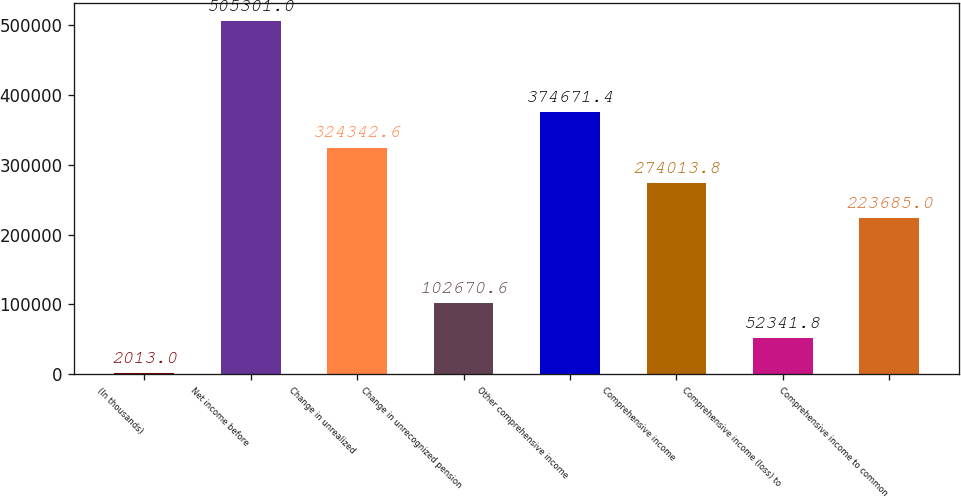<chart> <loc_0><loc_0><loc_500><loc_500><bar_chart><fcel>(In thousands)<fcel>Net income before<fcel>Change in unrealized<fcel>Change in unrecognized pension<fcel>Other comprehensive income<fcel>Comprehensive income<fcel>Comprehensive income (loss) to<fcel>Comprehensive income to common<nl><fcel>2013<fcel>505301<fcel>324343<fcel>102671<fcel>374671<fcel>274014<fcel>52341.8<fcel>223685<nl></chart> 